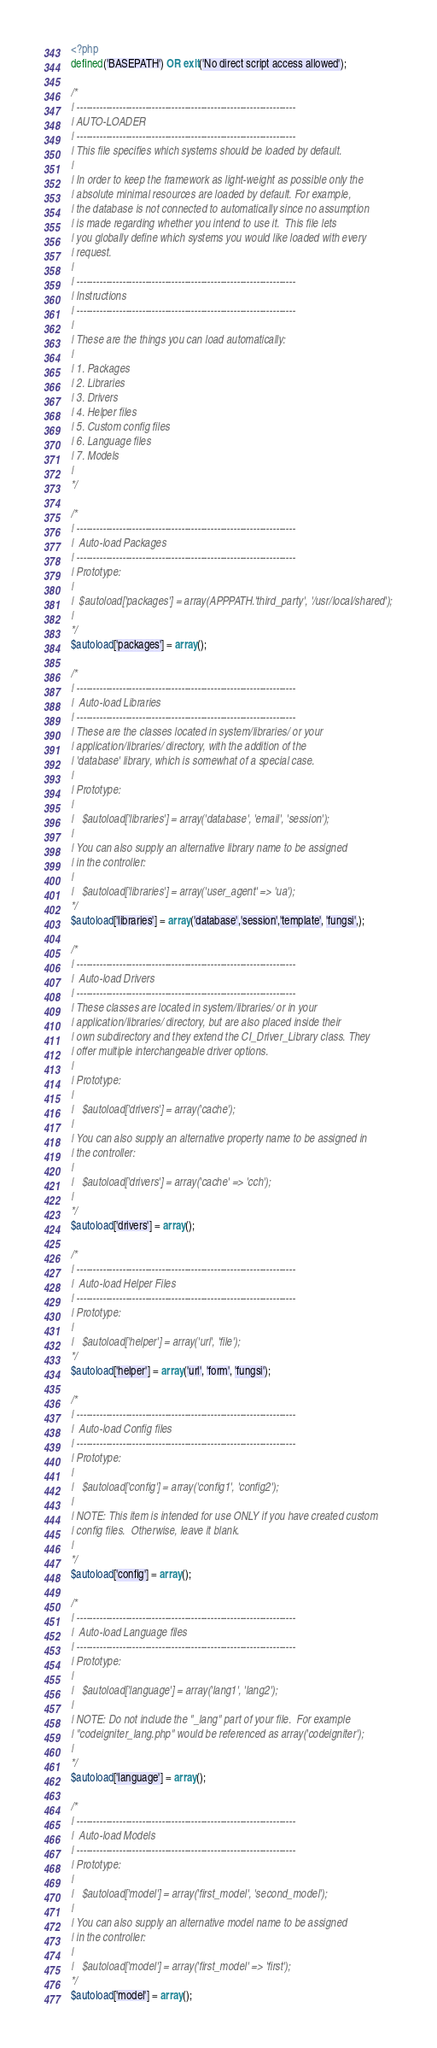<code> <loc_0><loc_0><loc_500><loc_500><_PHP_><?php
defined('BASEPATH') OR exit('No direct script access allowed');

/*
| -------------------------------------------------------------------
| AUTO-LOADER
| -------------------------------------------------------------------
| This file specifies which systems should be loaded by default.
|
| In order to keep the framework as light-weight as possible only the
| absolute minimal resources are loaded by default. For example,
| the database is not connected to automatically since no assumption
| is made regarding whether you intend to use it.  This file lets
| you globally define which systems you would like loaded with every
| request.
|
| -------------------------------------------------------------------
| Instructions
| -------------------------------------------------------------------
|
| These are the things you can load automatically:
|
| 1. Packages
| 2. Libraries
| 3. Drivers
| 4. Helper files
| 5. Custom config files
| 6. Language files
| 7. Models
|
*/

/*
| -------------------------------------------------------------------
|  Auto-load Packages
| -------------------------------------------------------------------
| Prototype:
|
|  $autoload['packages'] = array(APPPATH.'third_party', '/usr/local/shared');
|
*/
$autoload['packages'] = array();

/*
| -------------------------------------------------------------------
|  Auto-load Libraries
| -------------------------------------------------------------------
| These are the classes located in system/libraries/ or your
| application/libraries/ directory, with the addition of the
| 'database' library, which is somewhat of a special case.
|
| Prototype:
|
|	$autoload['libraries'] = array('database', 'email', 'session');
|
| You can also supply an alternative library name to be assigned
| in the controller:
|
|	$autoload['libraries'] = array('user_agent' => 'ua');
*/
$autoload['libraries'] = array('database','session','template', 'fungsi',);

/*
| -------------------------------------------------------------------
|  Auto-load Drivers
| -------------------------------------------------------------------
| These classes are located in system/libraries/ or in your
| application/libraries/ directory, but are also placed inside their
| own subdirectory and they extend the CI_Driver_Library class. They
| offer multiple interchangeable driver options.
|
| Prototype:
|
|	$autoload['drivers'] = array('cache');
|
| You can also supply an alternative property name to be assigned in
| the controller:
|
|	$autoload['drivers'] = array('cache' => 'cch');
|
*/
$autoload['drivers'] = array();

/*
| -------------------------------------------------------------------
|  Auto-load Helper Files
| -------------------------------------------------------------------
| Prototype:
|
|	$autoload['helper'] = array('url', 'file');
*/
$autoload['helper'] = array('url', 'form', 'fungsi');

/*
| -------------------------------------------------------------------
|  Auto-load Config files
| -------------------------------------------------------------------
| Prototype:
|
|	$autoload['config'] = array('config1', 'config2');
|
| NOTE: This item is intended for use ONLY if you have created custom
| config files.  Otherwise, leave it blank.
|
*/
$autoload['config'] = array();

/*
| -------------------------------------------------------------------
|  Auto-load Language files
| -------------------------------------------------------------------
| Prototype:
|
|	$autoload['language'] = array('lang1', 'lang2');
|
| NOTE: Do not include the "_lang" part of your file.  For example
| "codeigniter_lang.php" would be referenced as array('codeigniter');
|
*/
$autoload['language'] = array();

/*
| -------------------------------------------------------------------
|  Auto-load Models
| -------------------------------------------------------------------
| Prototype:
|
|	$autoload['model'] = array('first_model', 'second_model');
|
| You can also supply an alternative model name to be assigned
| in the controller:
|
|	$autoload['model'] = array('first_model' => 'first');
*/
$autoload['model'] = array();
</code> 